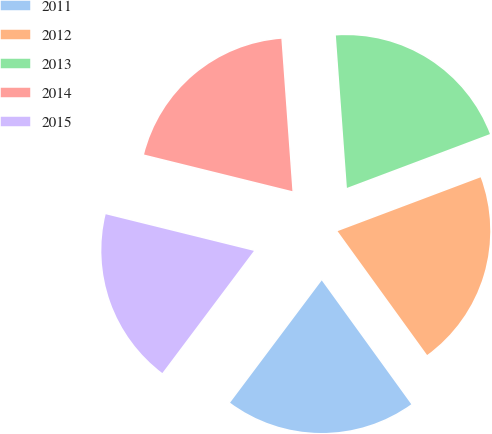<chart> <loc_0><loc_0><loc_500><loc_500><pie_chart><fcel>2011<fcel>2012<fcel>2013<fcel>2014<fcel>2015<nl><fcel>20.2%<fcel>20.77%<fcel>20.42%<fcel>19.99%<fcel>18.62%<nl></chart> 